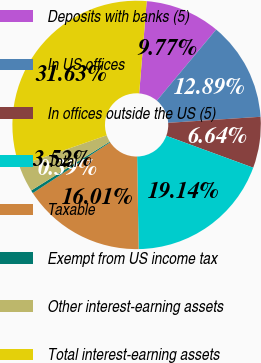<chart> <loc_0><loc_0><loc_500><loc_500><pie_chart><fcel>Deposits with banks (5)<fcel>In US offices<fcel>In offices outside the US (5)<fcel>Total<fcel>Taxable<fcel>Exempt from US income tax<fcel>Other interest-earning assets<fcel>Total interest-earning assets<nl><fcel>9.77%<fcel>12.89%<fcel>6.64%<fcel>19.14%<fcel>16.01%<fcel>0.39%<fcel>3.52%<fcel>31.63%<nl></chart> 